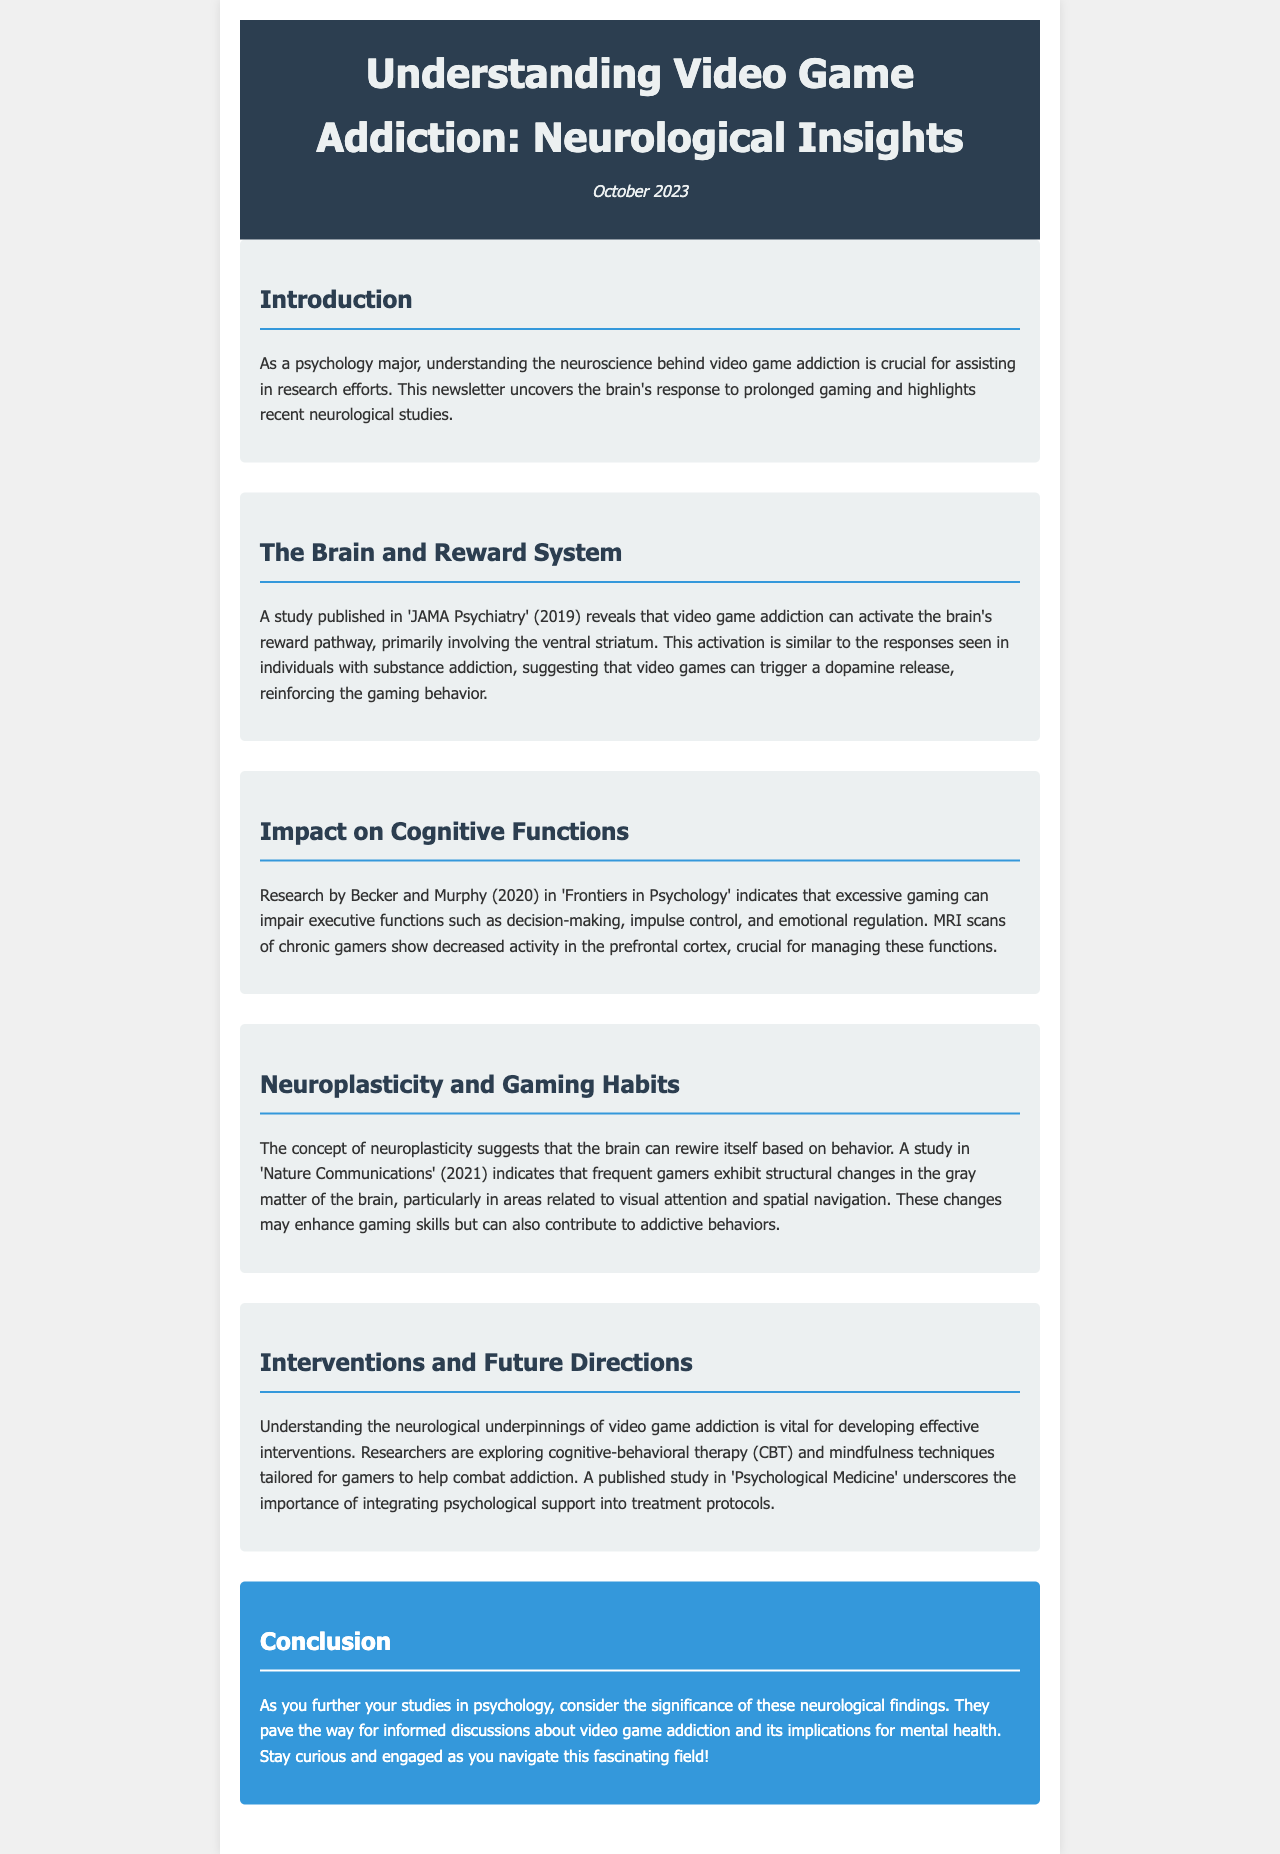what is the title of the newsletter? The title of the newsletter is prominently displayed in the header section.
Answer: Understanding Video Game Addiction: Neurological Insights when was the newsletter published? The publication date is included in the date section of the header.
Answer: October 2023 which brain area is primarily involved in the reward pathway activated by video game addiction? The document mentions the brain area involved in the reward pathway.
Answer: ventral striatum what cognitive functions are indicated to be impaired by excessive gaming? The document lists specific executive functions affected by excessive gaming.
Answer: decision-making, impulse control, emotional regulation which study demonstrates the neuroplasticity effects of frequent gaming? The document cites a study that indicates structural changes due to gaming behavior.
Answer: Nature Communications (2021) what therapeutic techniques are being explored to treat video game addiction? The newsletter discusses the types of therapy being investigated for addiction.
Answer: cognitive-behavioral therapy (CBT) and mindfulness techniques which journal published the study showing impairments in cognitive functions? The document references the journal where research on cognitive impairments was published.
Answer: Frontiers in Psychology what is the conclusion's focus in the newsletter? The conclusion highlights the importance of the neurological findings discussed.
Answer: neurological findings how does the document portray the relationship between gaming and dopamine release? The document summarizes the relationship between gaming and a specific neurotransmitter.
Answer: triggers a dopamine release 